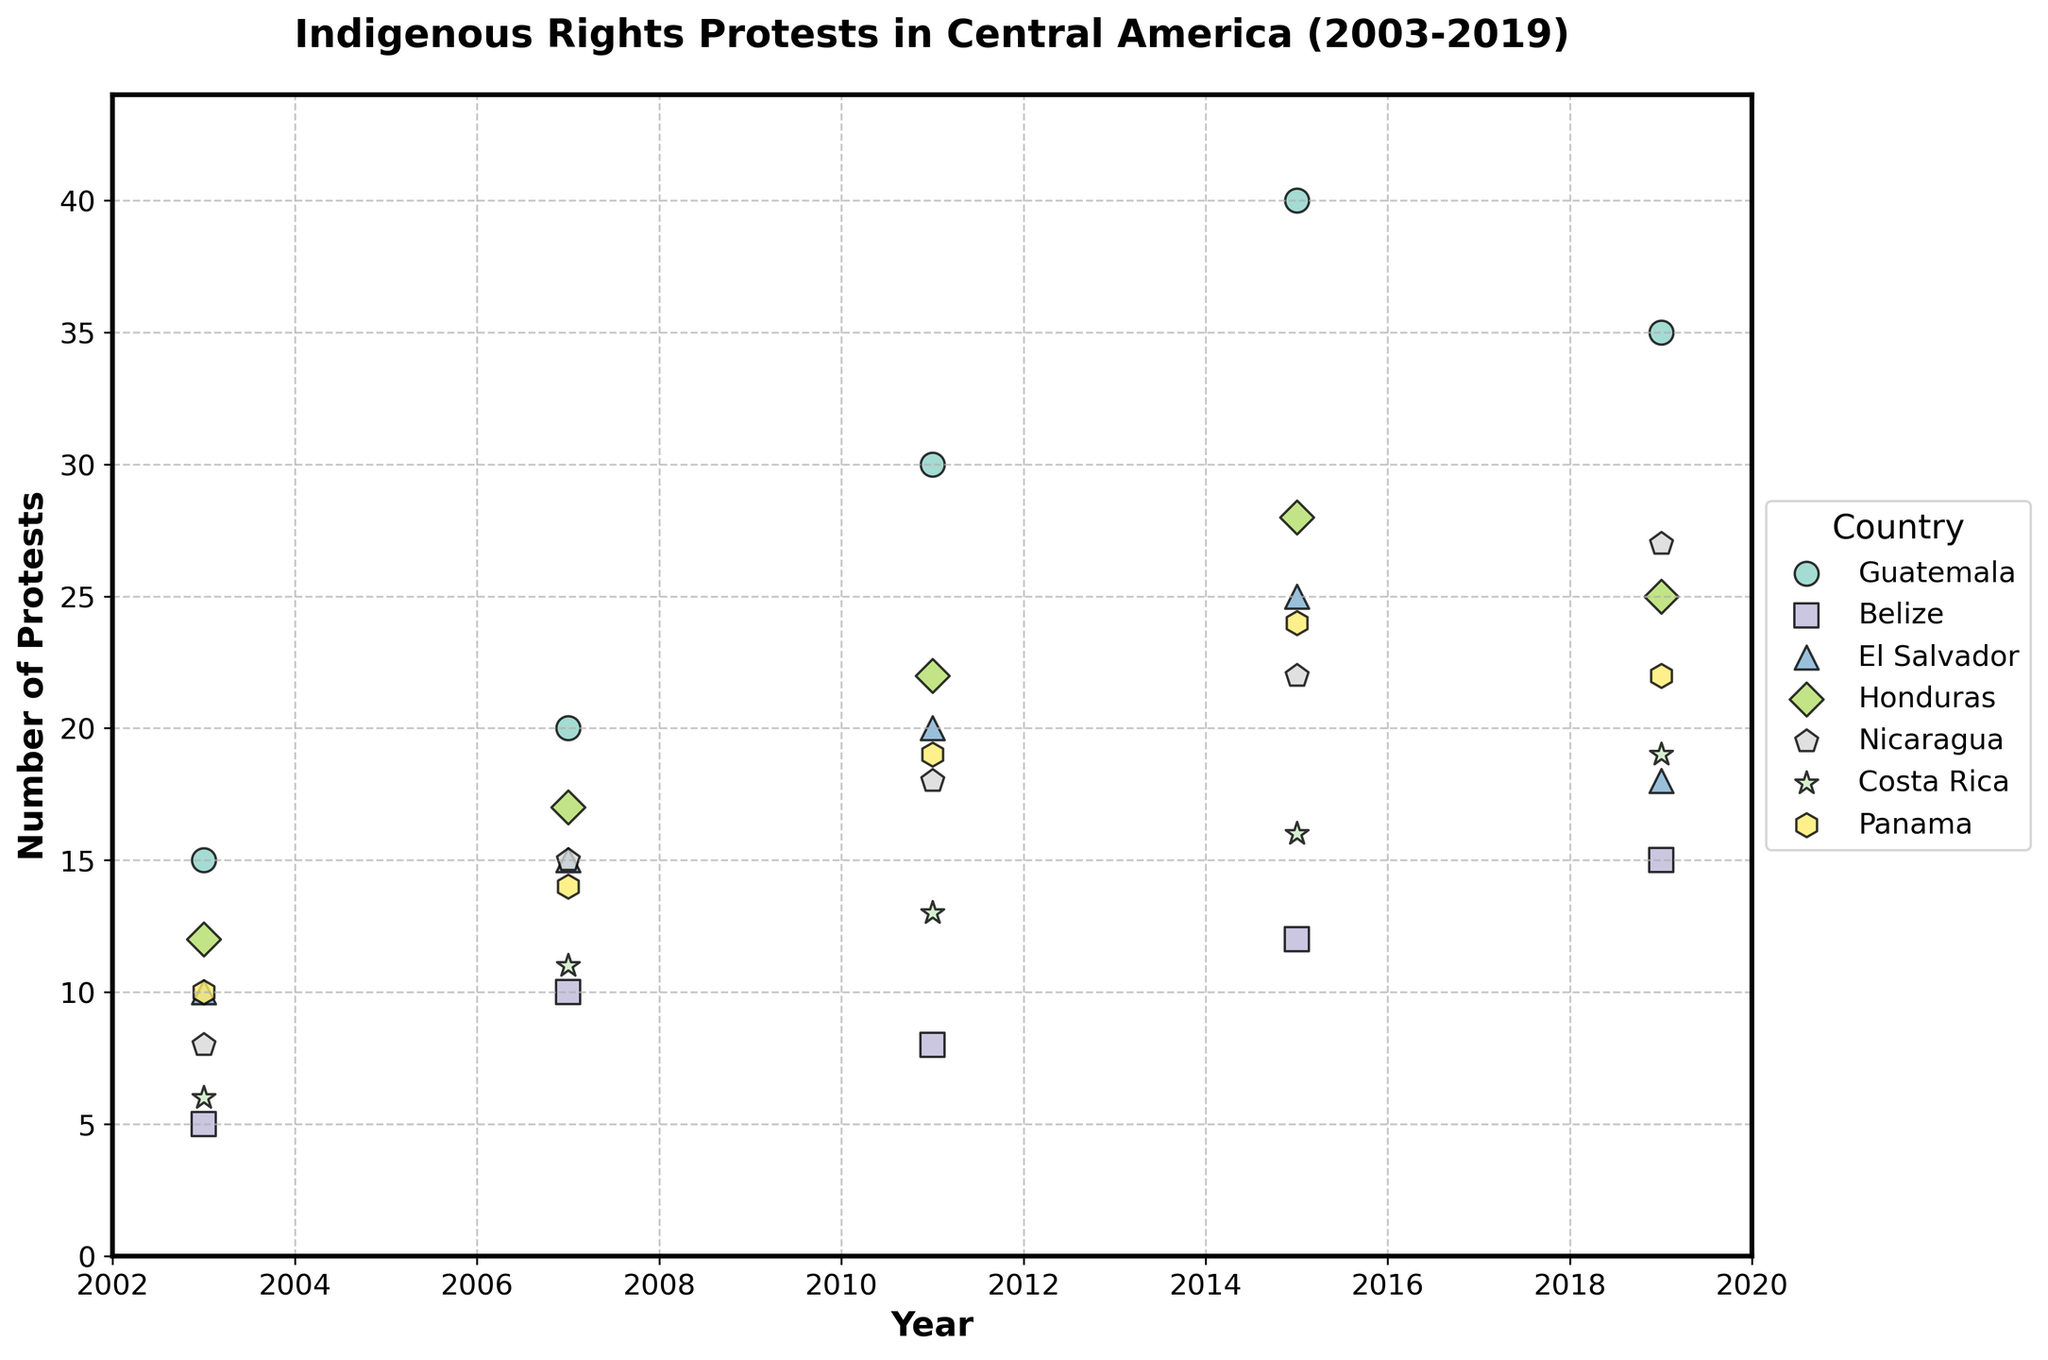What years are represented in the scatter plot? The x-axis label indicates that the years range from 2002 to 2020. Observing the data points, it's clear that the specific years included are 2003, 2007, 2011, 2015, and 2019.
Answer: 2003, 2007, 2011, 2015, 2019 Which country had the highest number of protests in 2015? By referring to the data points for the year 2015, Guatemala has the highest protest count, visually represented with the largest scatter point for that year.
Answer: Guatemala How many protests occurred in Belize in 2019? Look for the data point corresponding to Belize in the year 2019. The scatter plot shows a point at 15 protests.
Answer: 15 Which country shows a decreasing trend from 2015 to 2019 in the number of protests? Observe the points from 2015 to 2019 for each country. El Salvador's data points decrease from 25 in 2015 to 18 in 2019.
Answer: El Salvador What is the total number of protests reported in Honduras from 2003 to 2019? Sum the protests for Honduras across all the given years: 12 + 17 + 22 + 28 + 25 = 104.
Answer: 104 Which country has the least number of protests in 2011? By checking the data points for 2011, Belize has the lowest count with 8 protests.
Answer: Belize Compare the changes in protest numbers from 2003 to 2019 for Costa Rica and Panama. Which country shows a larger increase? Costa Rica increases from 6 to 19 protests, an increase of 13. Panama increases from 10 to 22 protests, an increase of 12. Thus, Costa Rica has a larger increase.
Answer: Costa Rica How do the number of protests in Guatemala in 2011 compare to those in Panama in 2015? Guatemala in 2011 has 30 protests, while Panama in 2015 has 24 protests. 30 is greater than 24.
Answer: Guatemala has more Which country had a steady increase in the number of protests in each recorded year? By examining the trend lines, Honduras has a consistent increase: 12 (2003), 17 (2007), 22 (2011), 28 (2015), and 25 (2019) (except a slight drop in 2019). Other countries have more fluctuations.
Answer: Honduras 